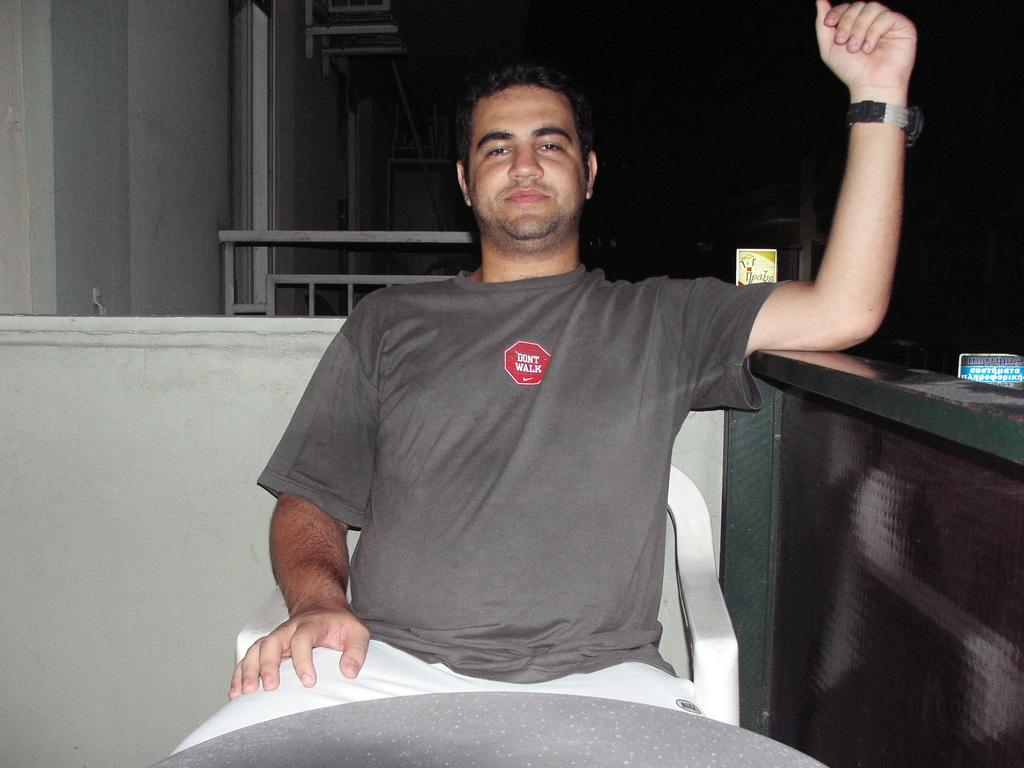What is the person in the image doing? There is a person sitting on a chair in the image. What can be seen in the background of the image? There are metal objects in the background of the image. What is the setting of the image? There is a wall visible in the image. What type of wing is attached to the person in the image? There is no wing attached to the person in the image. How does the wind affect the person sitting on the chair in the image? The image does not show any wind or its effects on the person sitting on the chair. 